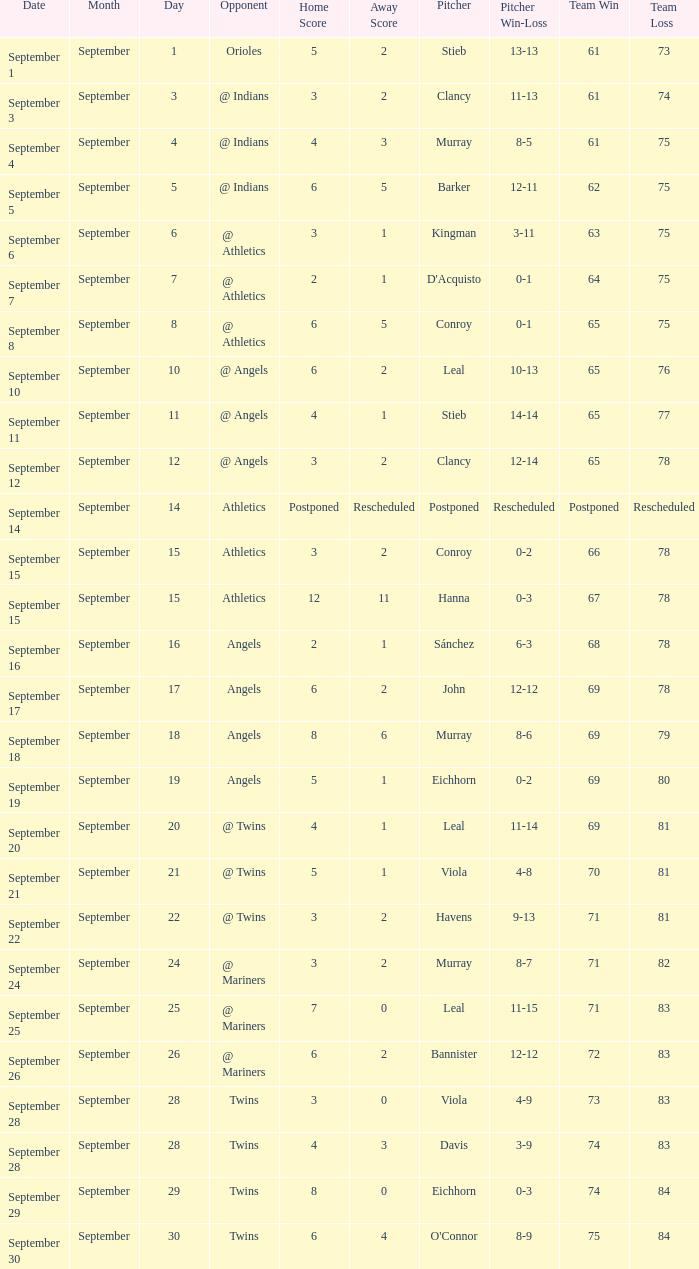Name the loss for record of 71-81 Havens (9-13). 